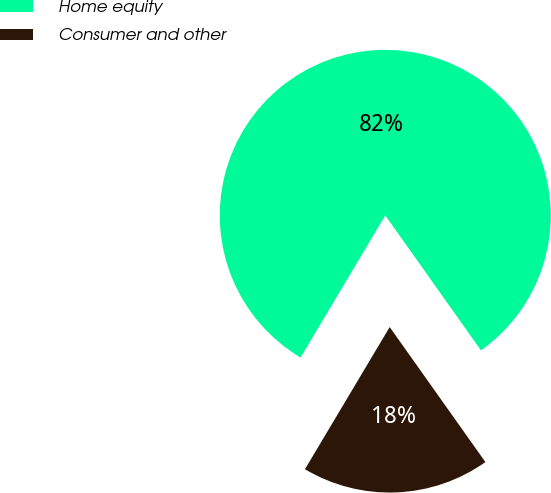Convert chart to OTSL. <chart><loc_0><loc_0><loc_500><loc_500><pie_chart><fcel>Home equity<fcel>Consumer and other<nl><fcel>81.63%<fcel>18.37%<nl></chart> 